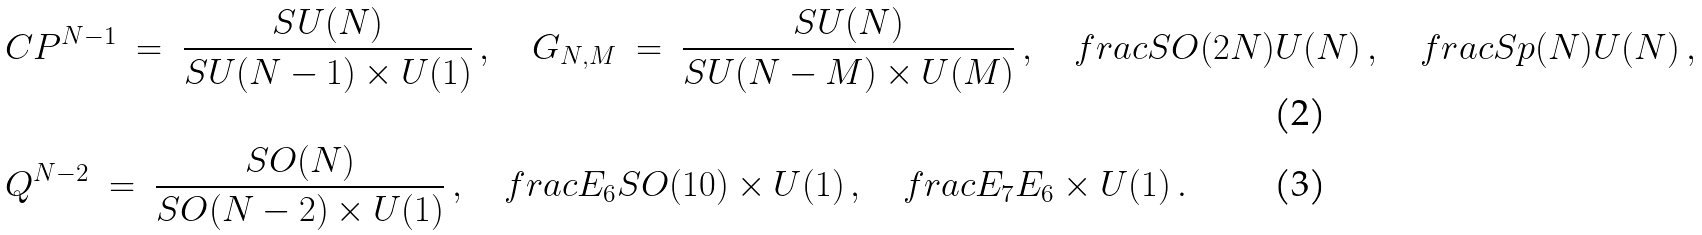<formula> <loc_0><loc_0><loc_500><loc_500>& { C } P ^ { N - 1 } \ = \ \frac { S U ( N ) } { S U ( N - 1 ) \times U ( 1 ) } \, , \quad G _ { N , M } \ = \ \frac { S U ( N ) } { S U ( N - M ) \times U ( M ) } \, , \quad f r a c { S O ( 2 N ) } { U ( N ) } \, , \quad f r a c { S p ( N ) } { U ( N ) } \, , \\ & Q ^ { N - 2 } \ = \ \frac { S O ( N ) } { S O ( N - 2 ) \times U ( 1 ) } \, , \quad f r a c { E _ { 6 } } { S O ( 1 0 ) \times U ( 1 ) } \, , \quad f r a c { E _ { 7 } } { E _ { 6 } \times U ( 1 ) } \, .</formula> 